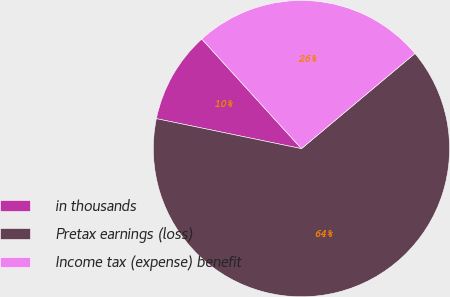Convert chart. <chart><loc_0><loc_0><loc_500><loc_500><pie_chart><fcel>in thousands<fcel>Pretax earnings (loss)<fcel>Income tax (expense) benefit<nl><fcel>10.01%<fcel>64.34%<fcel>25.64%<nl></chart> 